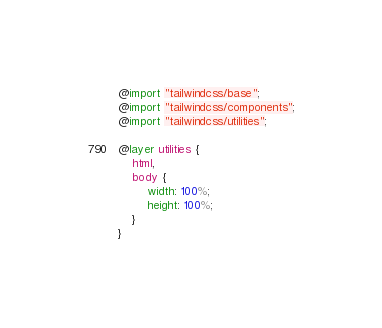Convert code to text. <code><loc_0><loc_0><loc_500><loc_500><_CSS_>@import "tailwindcss/base";
@import "tailwindcss/components";
@import "tailwindcss/utilities";

@layer utilities {
    html,
    body {
        width: 100%;
        height: 100%;
    }
}
</code> 